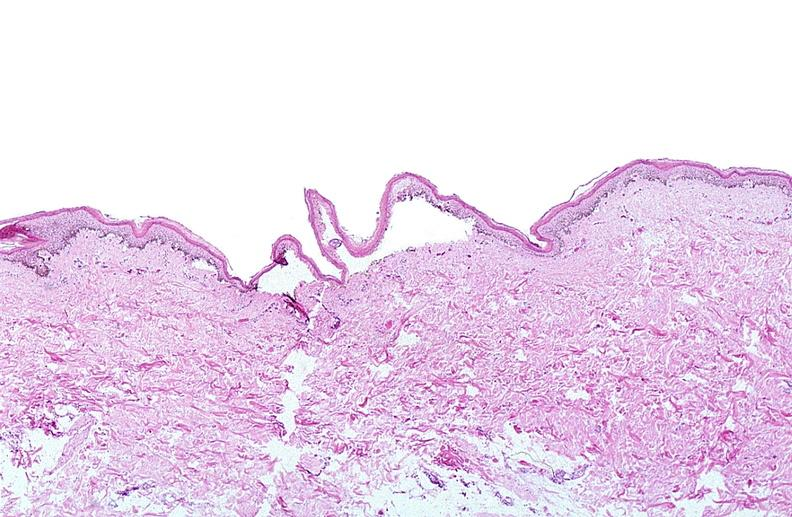where is this?
Answer the question using a single word or phrase. Skin 